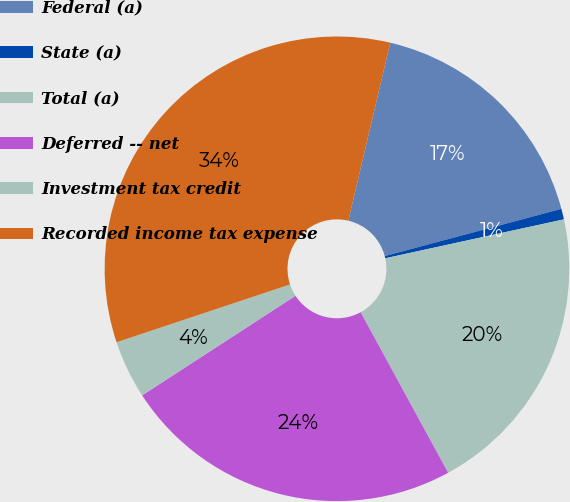Convert chart to OTSL. <chart><loc_0><loc_0><loc_500><loc_500><pie_chart><fcel>Federal (a)<fcel>State (a)<fcel>Total (a)<fcel>Deferred -- net<fcel>Investment tax credit<fcel>Recorded income tax expense<nl><fcel>17.16%<fcel>0.74%<fcel>20.47%<fcel>23.77%<fcel>4.05%<fcel>33.8%<nl></chart> 